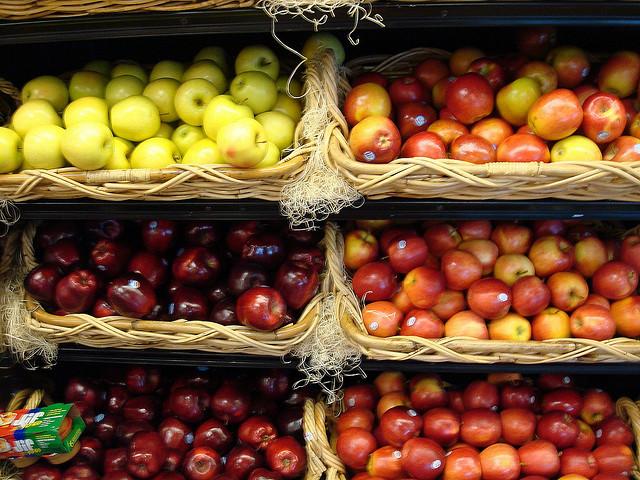Are all the fruits on display apples?
Write a very short answer. Yes. Are all the apples in baskets?
Quick response, please. Yes. Are all the apples the same color?
Write a very short answer. No. How many different kinds of apples are there?
Give a very brief answer. 3. 